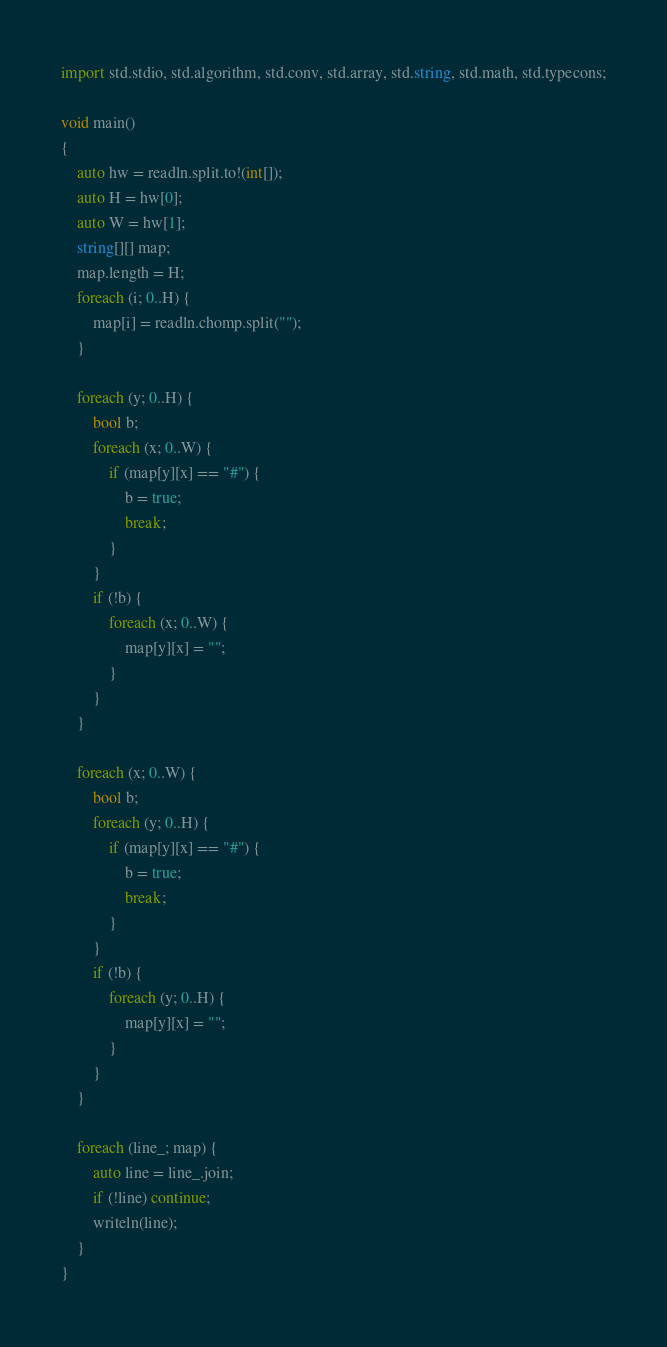<code> <loc_0><loc_0><loc_500><loc_500><_D_>import std.stdio, std.algorithm, std.conv, std.array, std.string, std.math, std.typecons;

void main()
{
    auto hw = readln.split.to!(int[]);
    auto H = hw[0];
    auto W = hw[1];
    string[][] map;
    map.length = H;
    foreach (i; 0..H) {
        map[i] = readln.chomp.split("");
    }

    foreach (y; 0..H) {
        bool b;
        foreach (x; 0..W) {
            if (map[y][x] == "#") {
                b = true;
                break;
            }
        }
        if (!b) {
            foreach (x; 0..W) {
                map[y][x] = "";
            }
        }
    }

    foreach (x; 0..W) {
        bool b;
        foreach (y; 0..H) {
            if (map[y][x] == "#") {
                b = true;
                break;
            }
        }
        if (!b) {
            foreach (y; 0..H) {
                map[y][x] = "";
            }
        }
    }

    foreach (line_; map) {
        auto line = line_.join;
        if (!line) continue;
        writeln(line);
    }
}</code> 